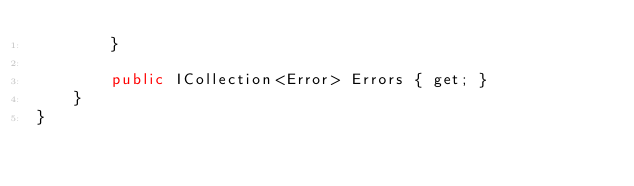<code> <loc_0><loc_0><loc_500><loc_500><_C#_>        }

        public ICollection<Error> Errors { get; }
    }
}</code> 